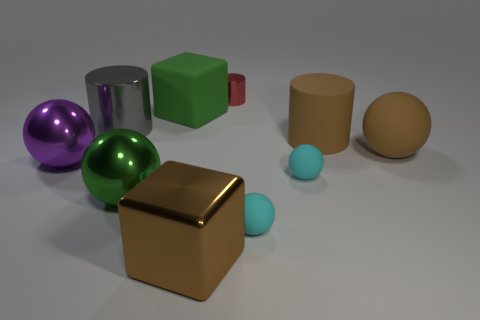Can you describe the lighting and shadows in the scene? The lighting appears to be coming from the upper left, as evidenced by the placement of shadows to the right of the objects. There's a soft light effect creating gentle shadows, which gives the scene a calm and evenly lit appearance. 